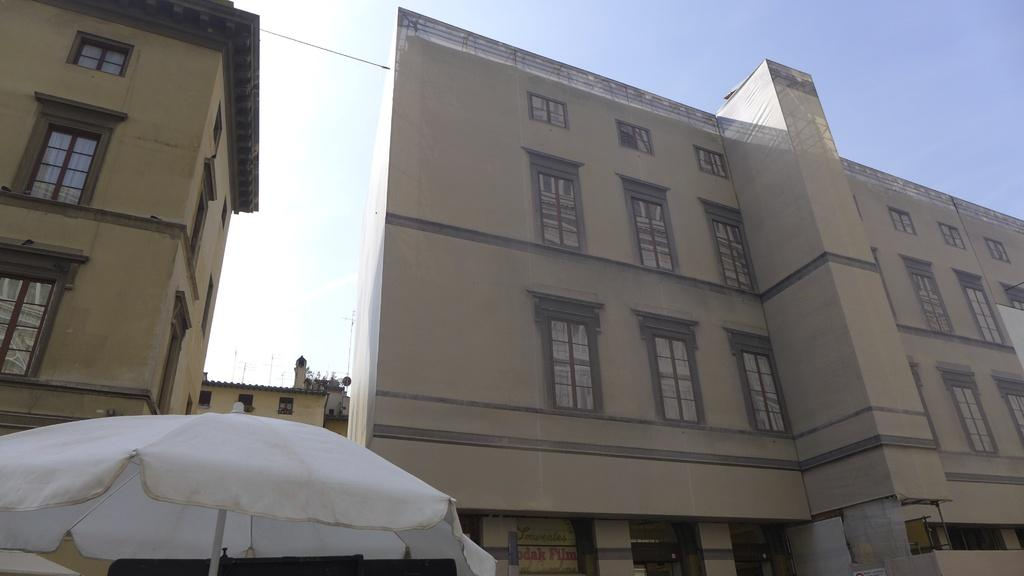How many buildings are present in the image? There are two buildings in the picture. What feature do the buildings have in common? The buildings have windows. What object can be seen in the picture that provides shade? There is a white color umbrella in the picture. What is the condition of the sky in the image? The sky is clear in the image. Can you tell me how many lizards are sitting on the windows of the buildings in the image? There are no lizards present in the image; the buildings have windows, but no lizards are visible. 